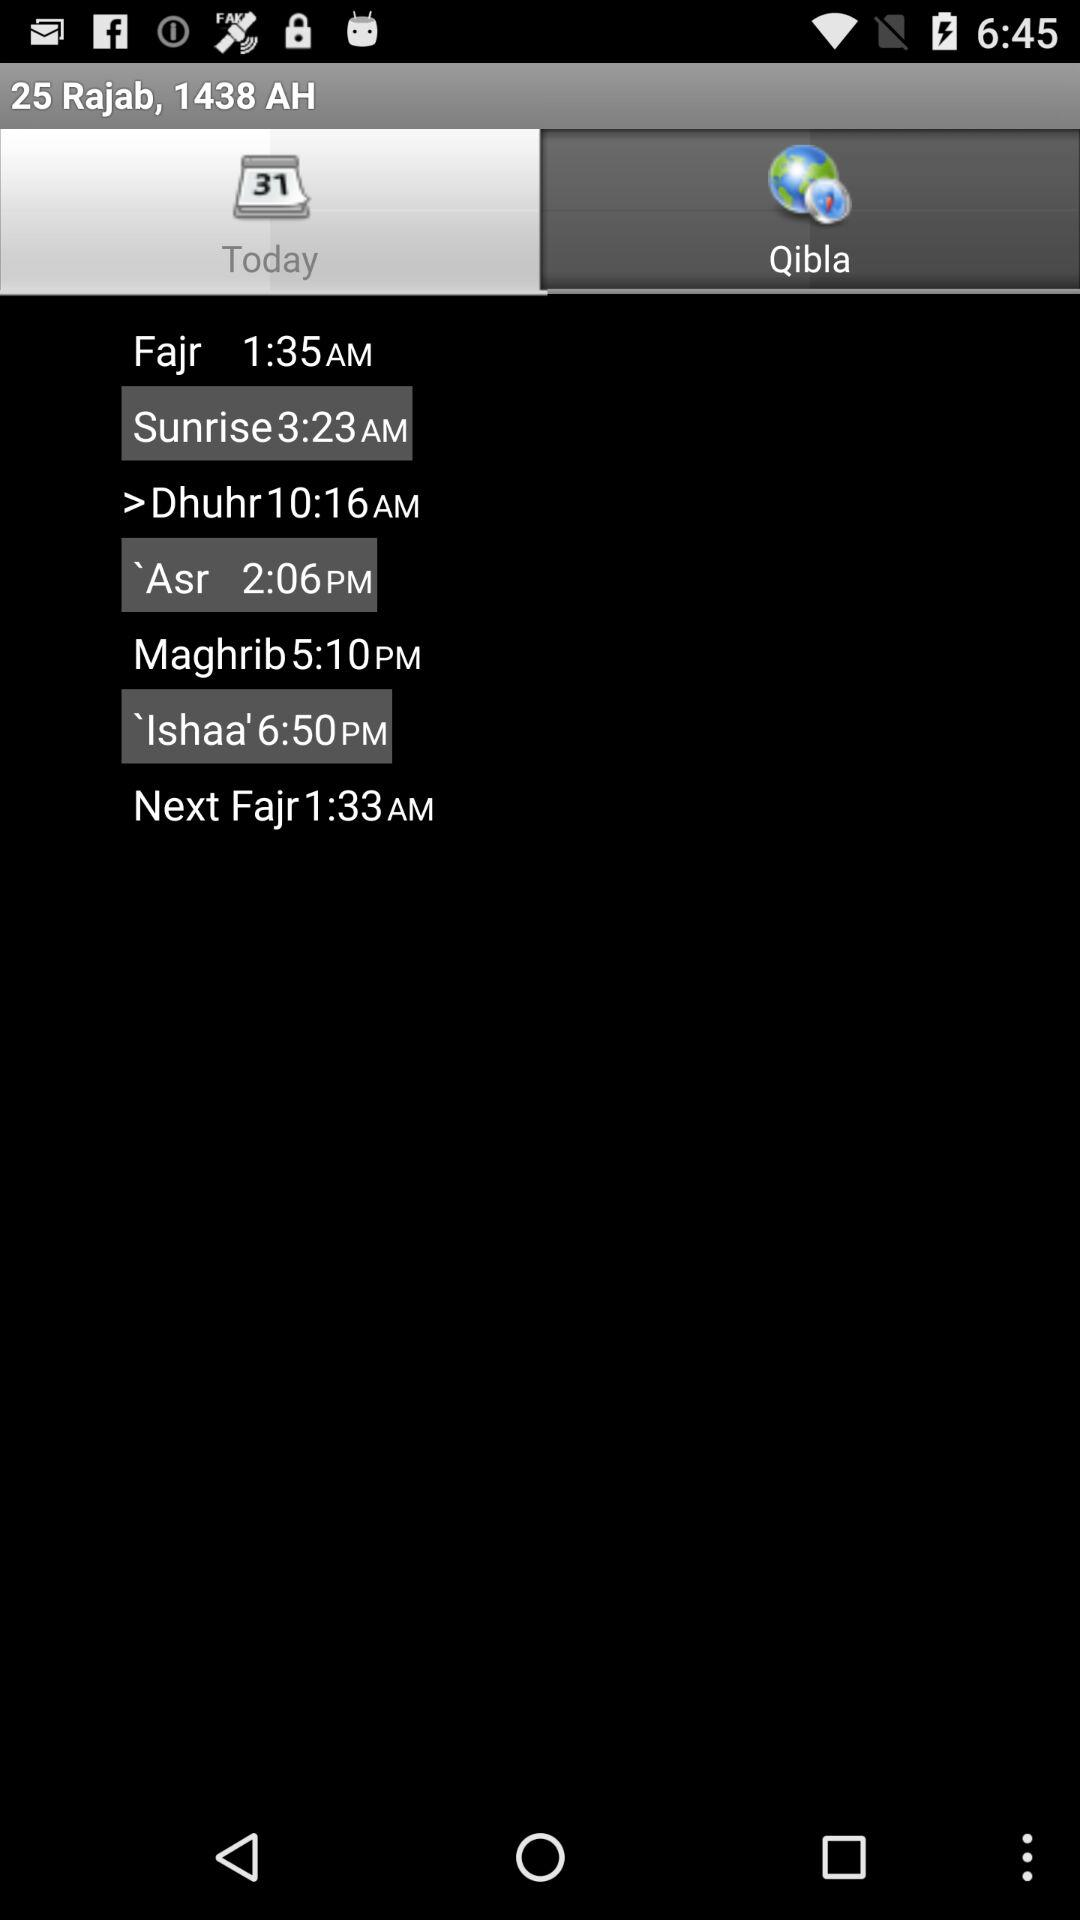Which tab has been selected? The tab "Today" has been selected. 